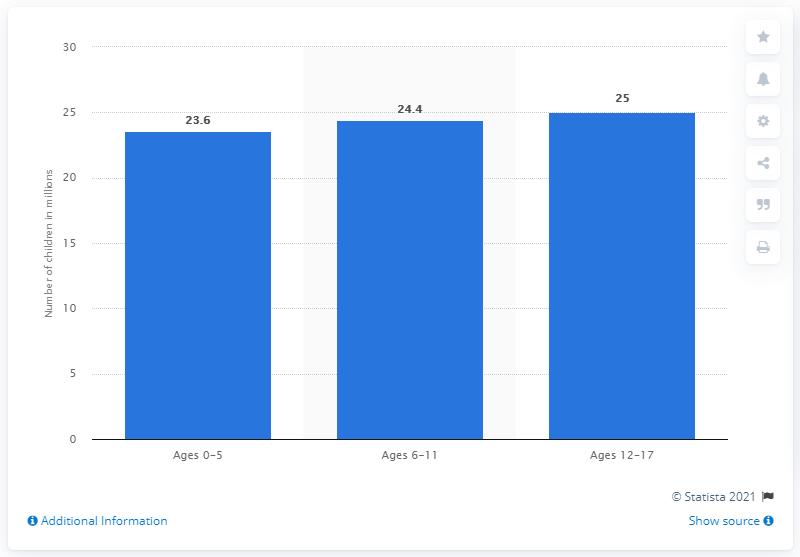Outline some significant characteristics in this image. The number of children in the United States in 2019 was approximately 25. In 2019, the number of children in the United States was 23.6. 